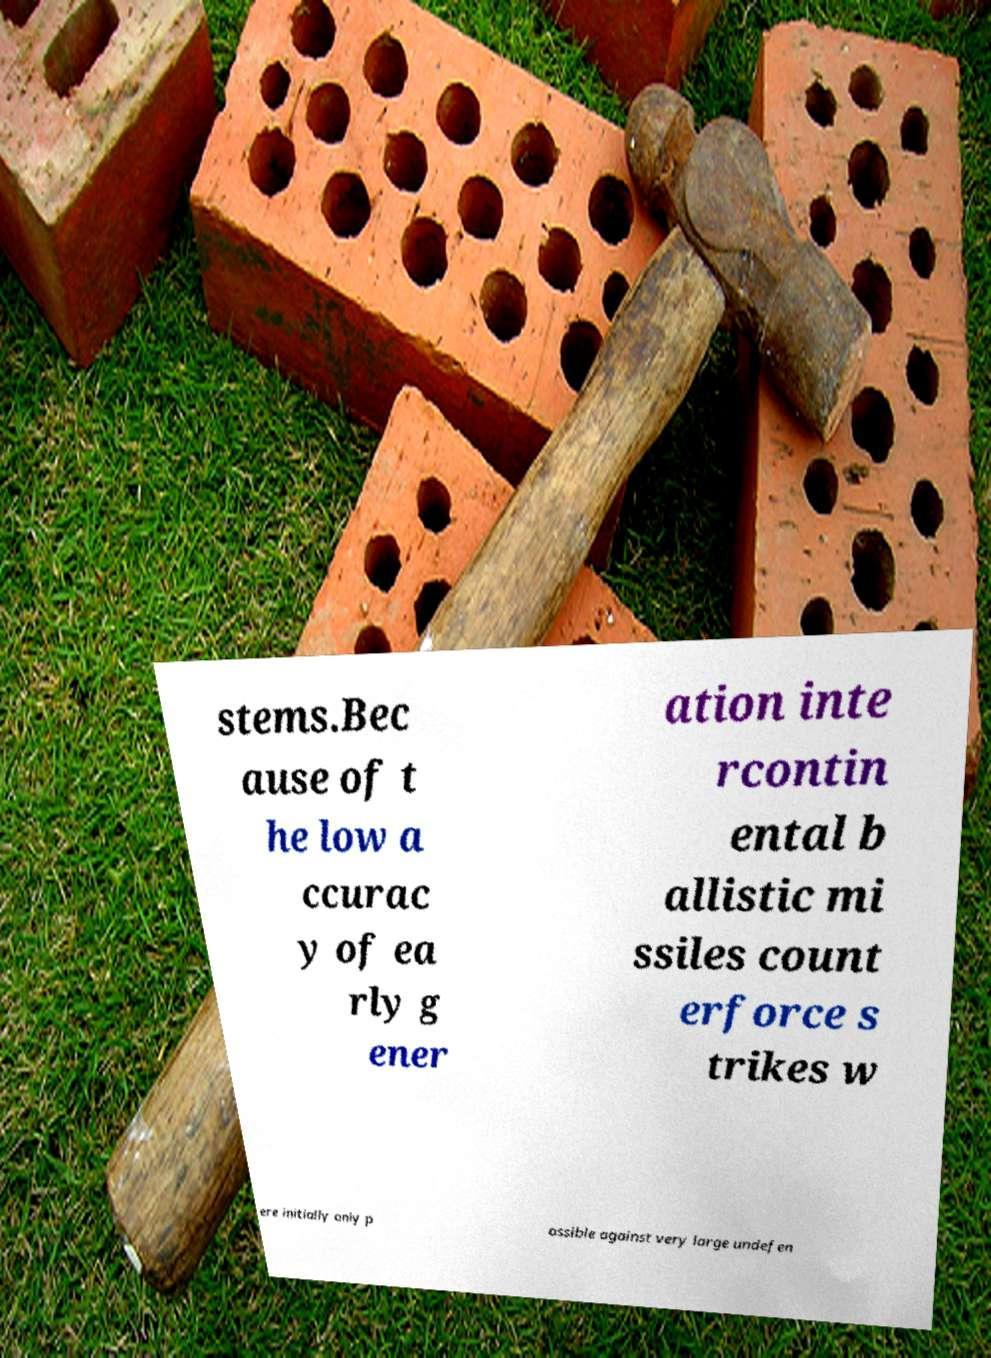Please identify and transcribe the text found in this image. stems.Bec ause of t he low a ccurac y of ea rly g ener ation inte rcontin ental b allistic mi ssiles count erforce s trikes w ere initially only p ossible against very large undefen 